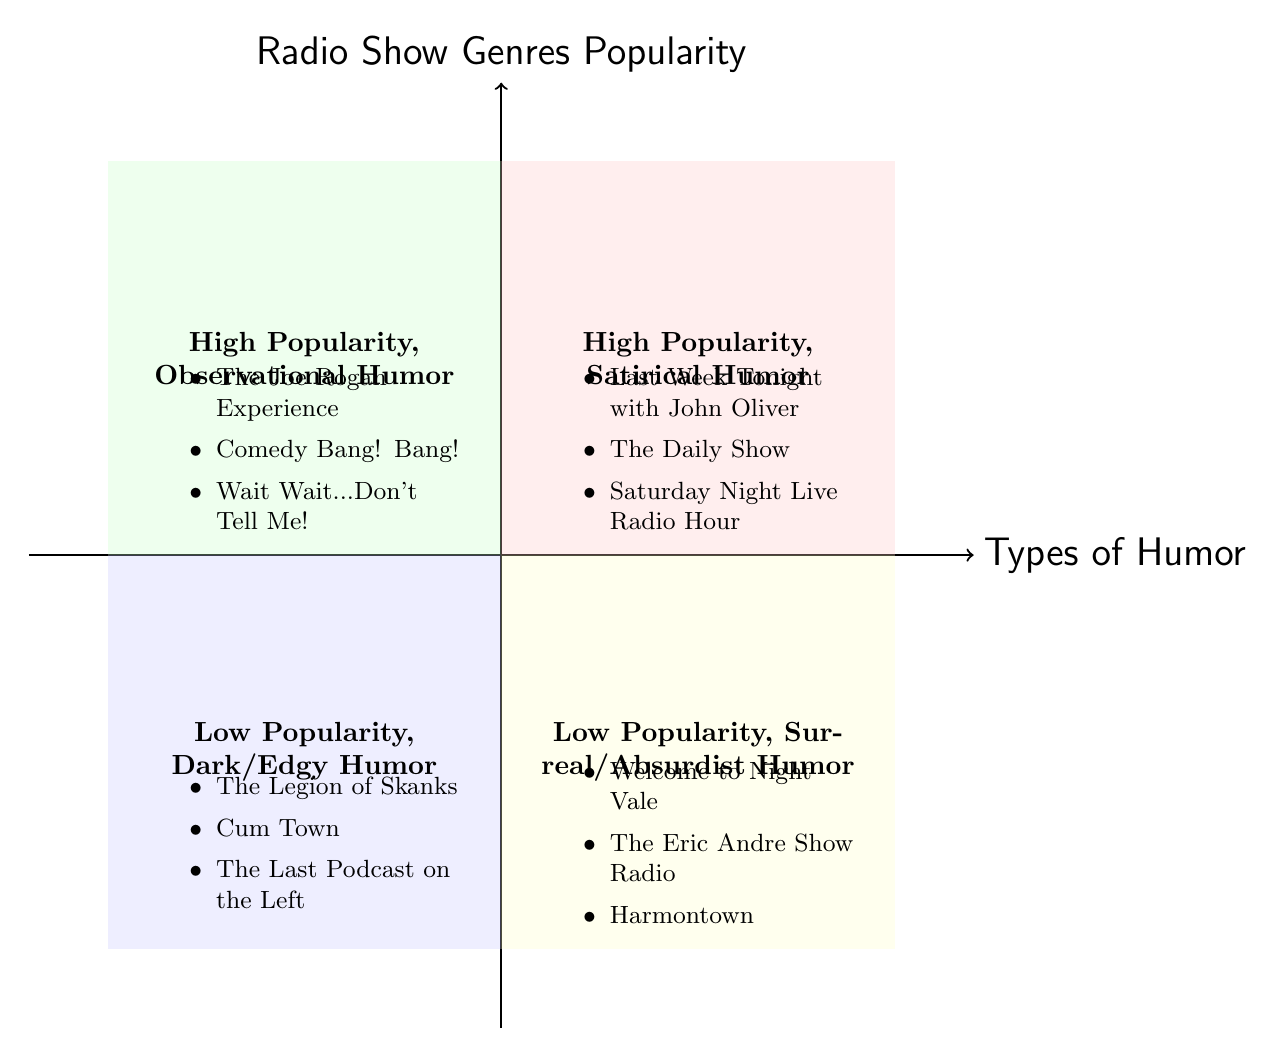What types of humor are represented in the high popularity quadrants? The high popularity quadrants are the top left and top right sections of the chart, which represent "High Popularity, Satirical Humor" and "High Popularity, Observational Humor."
Answer: Satirical Humor, Observational Humor How many examples are given for low popularity, dark/edgy humor? The quadrant labeled "Low Popularity, Dark/Edgy Humor" has three specific examples listed below it.
Answer: 3 Which radio show genre appears in the high popularity, satirical humor quadrant? The quadrant named "High Popularity, Satirical Humor" includes several radio shows, so I can look to see which specific ones are listed there, such as "Last Week Tonight with John Oliver."
Answer: Last Week Tonight with John Oliver How many types of humor are associated with high popularity? By observing the two high popularity quadrants and summing the two distinct types of humor they represent, I find both "Satirical Humor" and "Observational Humor" are listed.
Answer: 2 What is the relationship between "The Eric Andre Show Radio" and “Low Popularity”? "The Eric Andre Show Radio" is listed in the "Low Popularity, Surreal/Absurdist Humor" quadrant, indicating that it falls under the category of humor that is less popular according to this diagram.
Answer: Low Popularity Which quadrant has the most examples? By counting the number of examples in each quadrant, I find that both "High Popularity, Satirical Humor" and "High Popularity, Observational Humor" contain three examples, while the low popularity quadrants also contain three examples. Thus, no other quadrant has more than three examples.
Answer: All quadrants have the same number 